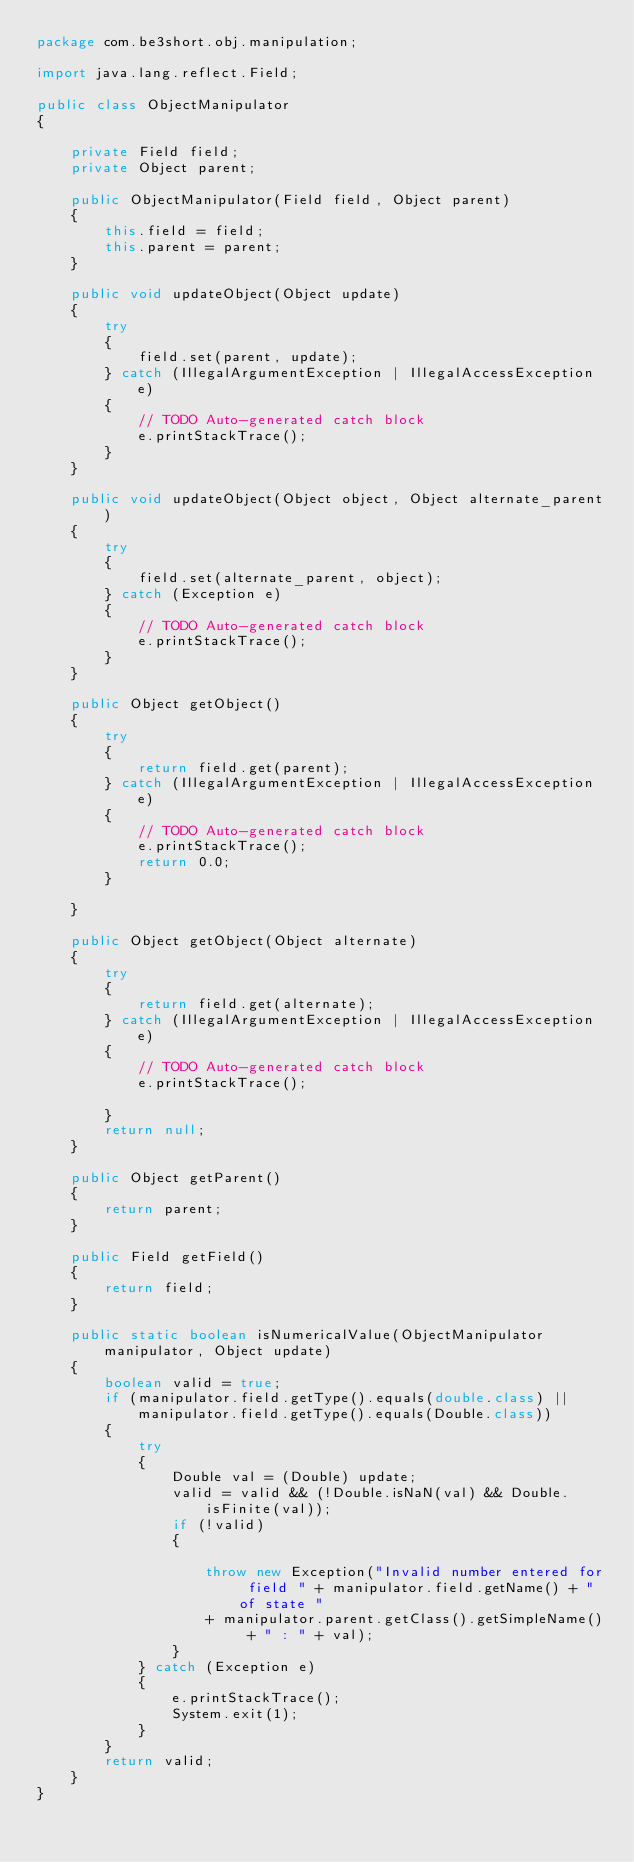Convert code to text. <code><loc_0><loc_0><loc_500><loc_500><_Java_>package com.be3short.obj.manipulation;

import java.lang.reflect.Field;

public class ObjectManipulator
{

	private Field field;
	private Object parent;

	public ObjectManipulator(Field field, Object parent)
	{
		this.field = field;
		this.parent = parent;
	}

	public void updateObject(Object update)
	{
		try
		{
			field.set(parent, update);
		} catch (IllegalArgumentException | IllegalAccessException e)
		{
			// TODO Auto-generated catch block
			e.printStackTrace();
		}
	}

	public void updateObject(Object object, Object alternate_parent)
	{
		try
		{
			field.set(alternate_parent, object);
		} catch (Exception e)
		{
			// TODO Auto-generated catch block
			e.printStackTrace();
		}
	}

	public Object getObject()
	{
		try
		{
			return field.get(parent);
		} catch (IllegalArgumentException | IllegalAccessException e)
		{
			// TODO Auto-generated catch block
			e.printStackTrace();
			return 0.0;
		}

	}

	public Object getObject(Object alternate)
	{
		try
		{
			return field.get(alternate);
		} catch (IllegalArgumentException | IllegalAccessException e)
		{
			// TODO Auto-generated catch block
			e.printStackTrace();

		}
		return null;
	}

	public Object getParent()
	{
		return parent;
	}

	public Field getField()
	{
		return field;
	}

	public static boolean isNumericalValue(ObjectManipulator manipulator, Object update)
	{
		boolean valid = true;
		if (manipulator.field.getType().equals(double.class) || manipulator.field.getType().equals(Double.class))
		{
			try
			{
				Double val = (Double) update;
				valid = valid && (!Double.isNaN(val) && Double.isFinite(val));
				if (!valid)
				{

					throw new Exception("Invalid number entered for field " + manipulator.field.getName() + " of state "
					+ manipulator.parent.getClass().getSimpleName() + " : " + val);
				}
			} catch (Exception e)
			{
				e.printStackTrace();
				System.exit(1);
			}
		}
		return valid;
	}
}
</code> 